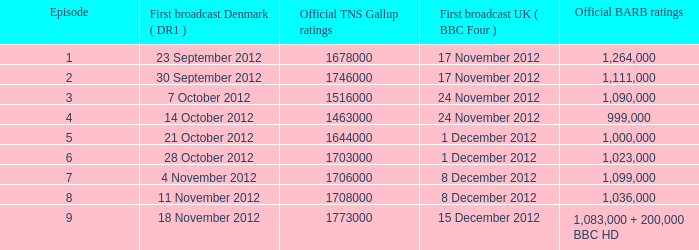What is the BARB ratings of episode 6? 1023000.0. 